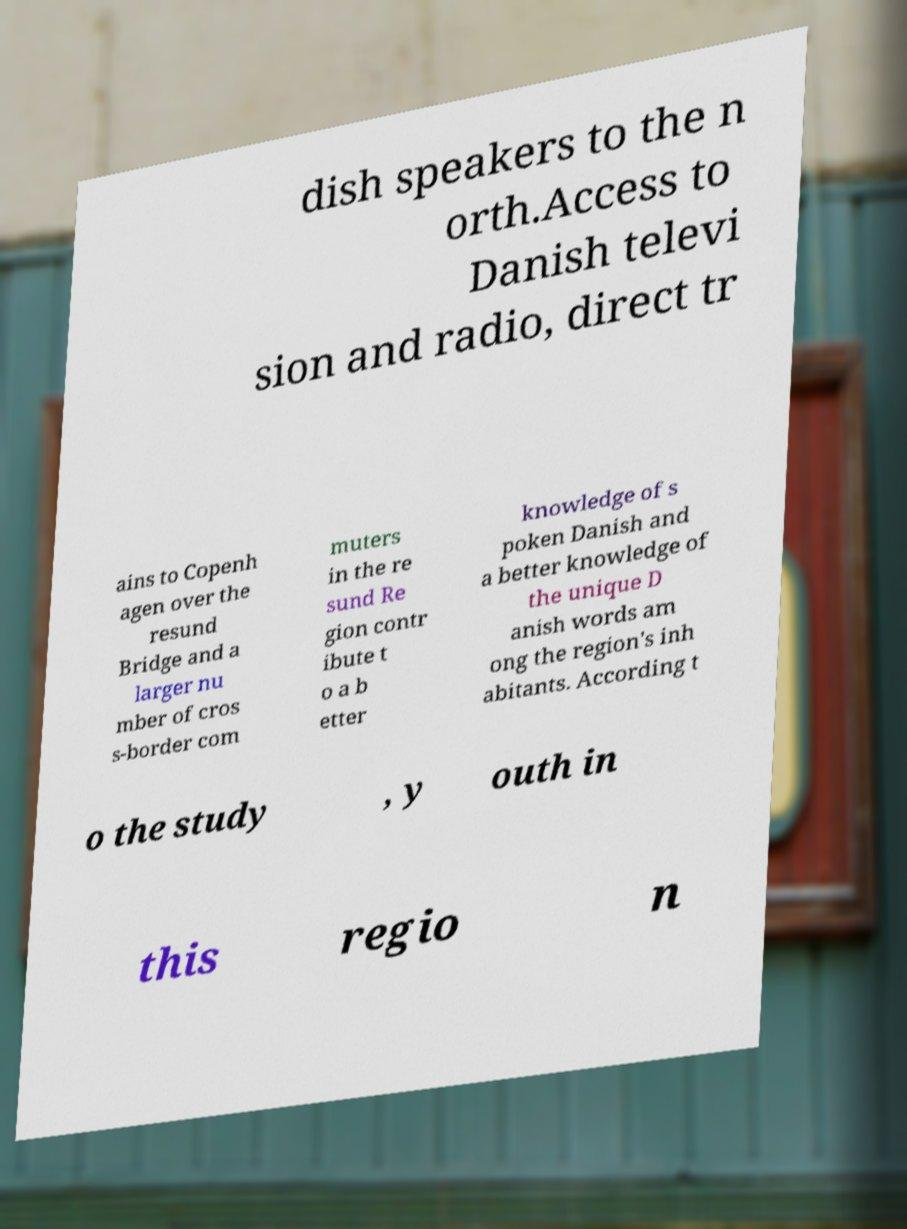There's text embedded in this image that I need extracted. Can you transcribe it verbatim? dish speakers to the n orth.Access to Danish televi sion and radio, direct tr ains to Copenh agen over the resund Bridge and a larger nu mber of cros s-border com muters in the re sund Re gion contr ibute t o a b etter knowledge of s poken Danish and a better knowledge of the unique D anish words am ong the region's inh abitants. According t o the study , y outh in this regio n 